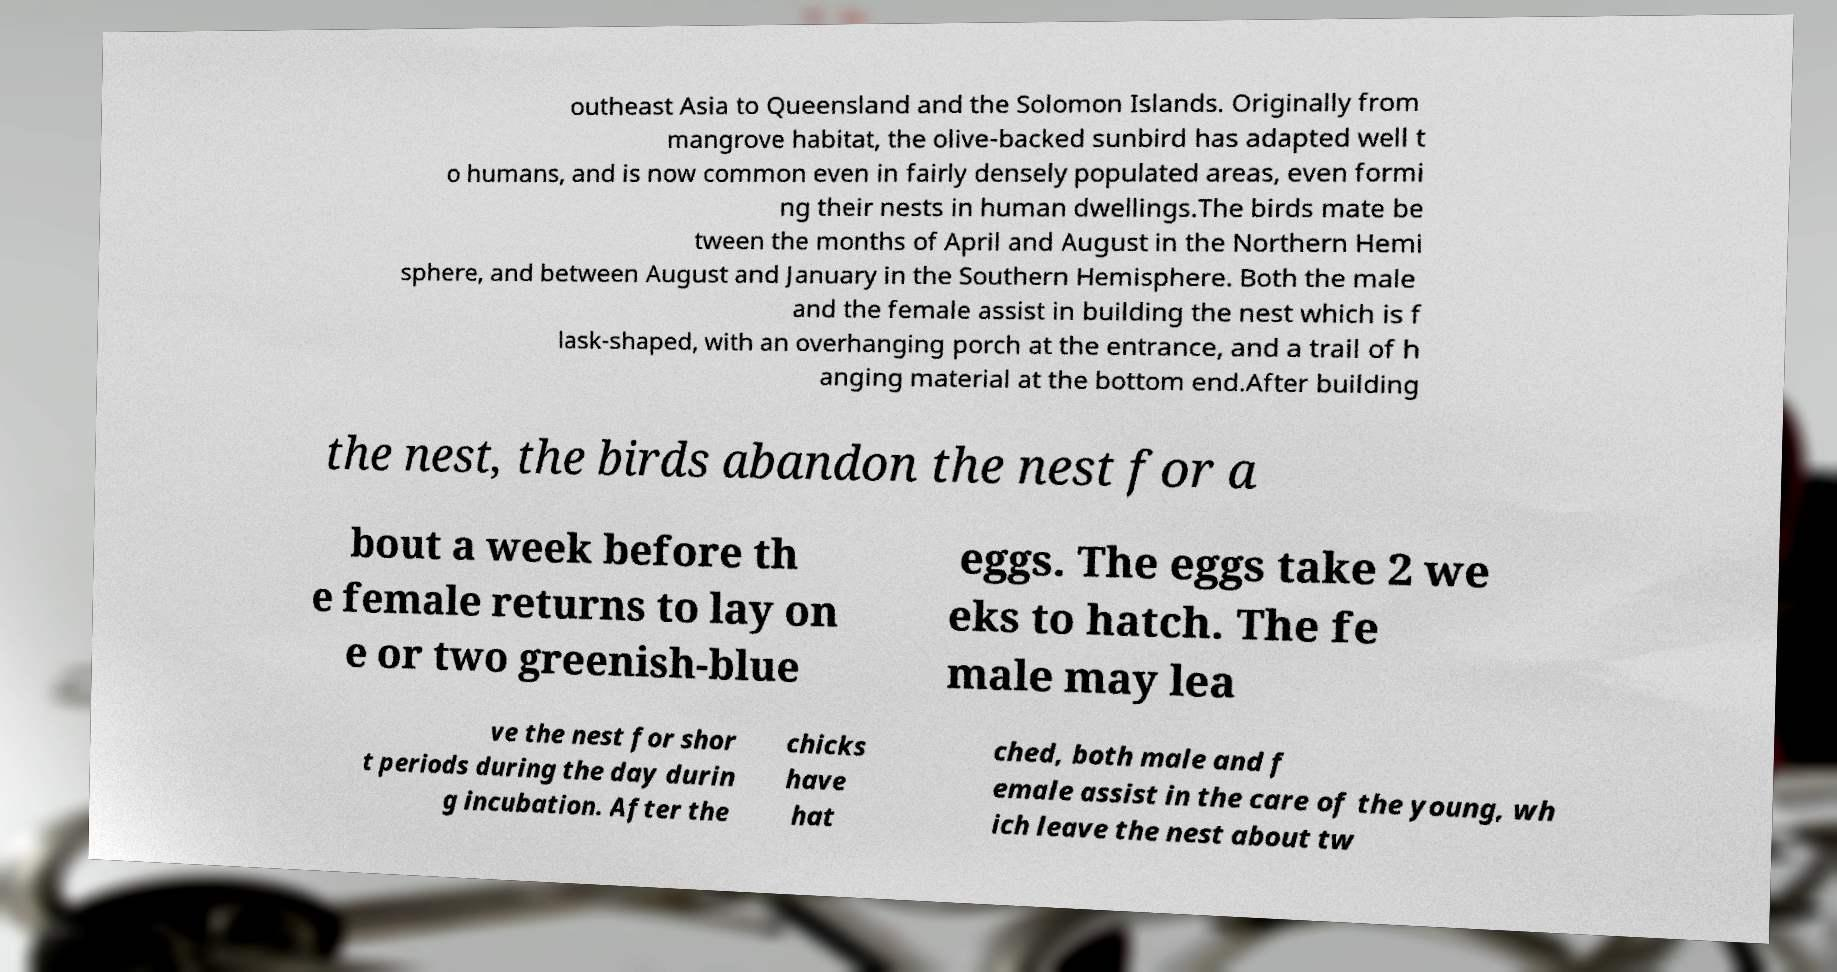For documentation purposes, I need the text within this image transcribed. Could you provide that? outheast Asia to Queensland and the Solomon Islands. Originally from mangrove habitat, the olive-backed sunbird has adapted well t o humans, and is now common even in fairly densely populated areas, even formi ng their nests in human dwellings.The birds mate be tween the months of April and August in the Northern Hemi sphere, and between August and January in the Southern Hemisphere. Both the male and the female assist in building the nest which is f lask-shaped, with an overhanging porch at the entrance, and a trail of h anging material at the bottom end.After building the nest, the birds abandon the nest for a bout a week before th e female returns to lay on e or two greenish-blue eggs. The eggs take 2 we eks to hatch. The fe male may lea ve the nest for shor t periods during the day durin g incubation. After the chicks have hat ched, both male and f emale assist in the care of the young, wh ich leave the nest about tw 